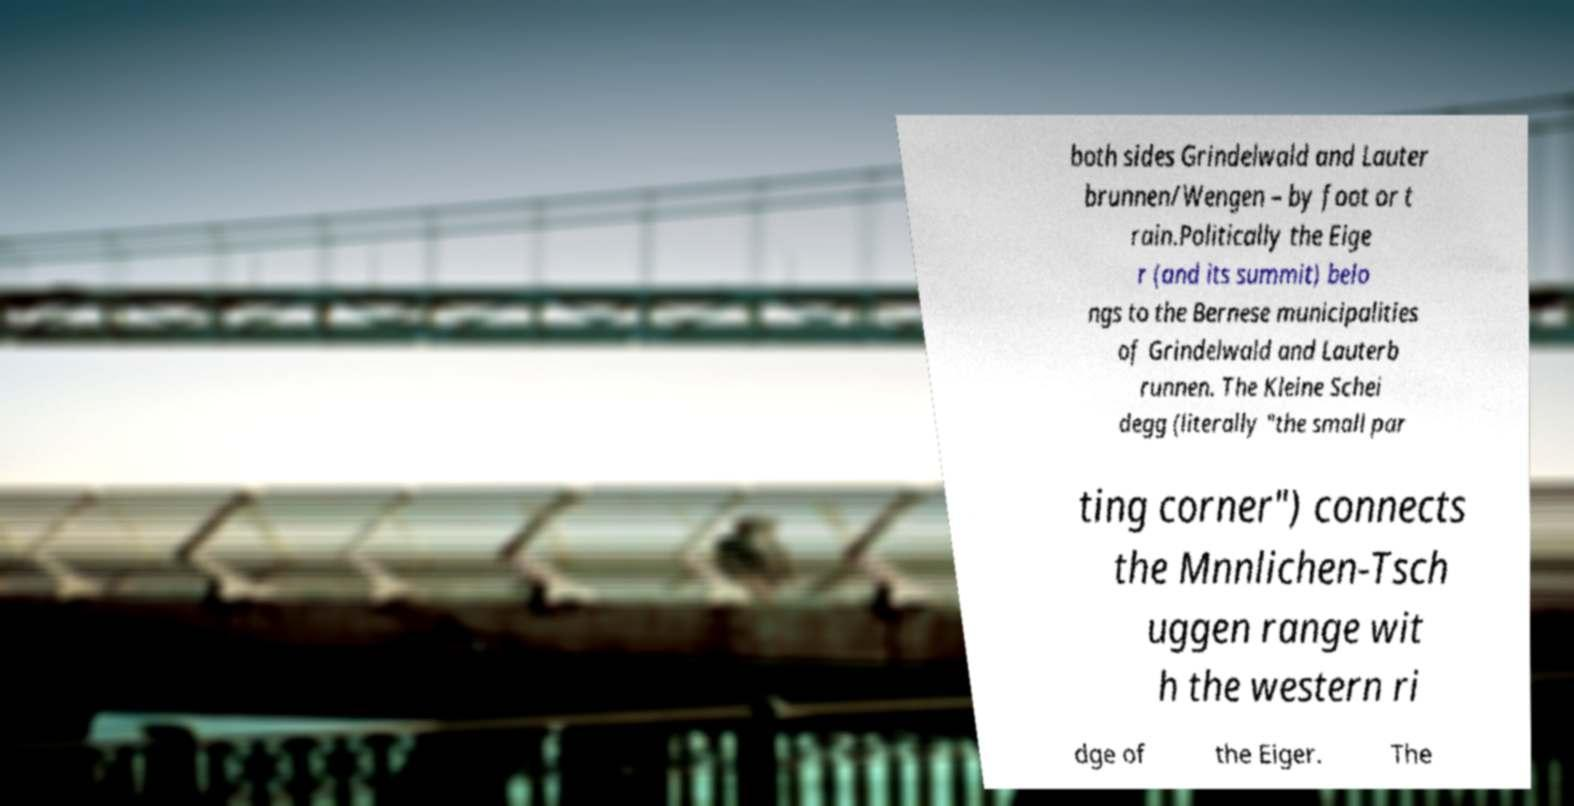Please identify and transcribe the text found in this image. both sides Grindelwald and Lauter brunnen/Wengen – by foot or t rain.Politically the Eige r (and its summit) belo ngs to the Bernese municipalities of Grindelwald and Lauterb runnen. The Kleine Schei degg (literally "the small par ting corner") connects the Mnnlichen-Tsch uggen range wit h the western ri dge of the Eiger. The 